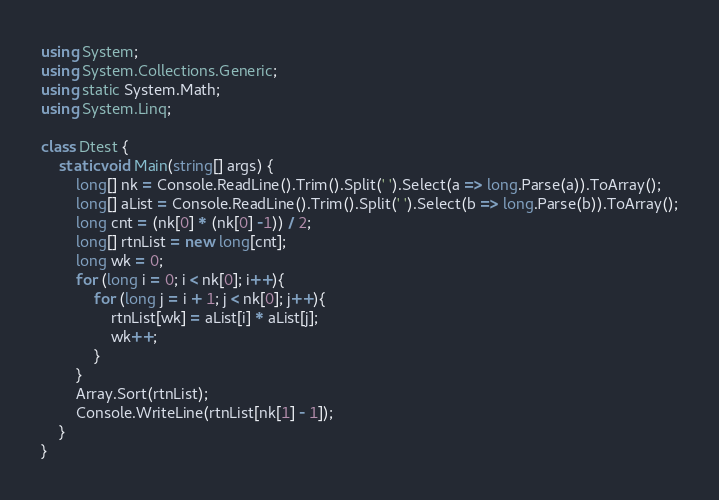Convert code to text. <code><loc_0><loc_0><loc_500><loc_500><_C#_>using System;
using System.Collections.Generic;
using static System.Math;
using System.Linq;

class Dtest {
    static void Main(string[] args) {
        long[] nk = Console.ReadLine().Trim().Split(' ').Select(a => long.Parse(a)).ToArray();
        long[] aList = Console.ReadLine().Trim().Split(' ').Select(b => long.Parse(b)).ToArray();
        long cnt = (nk[0] * (nk[0] -1)) / 2;
        long[] rtnList = new long[cnt];
        long wk = 0;
        for (long i = 0; i < nk[0]; i++){
            for (long j = i + 1; j < nk[0]; j++){
                rtnList[wk] = aList[i] * aList[j];
                wk++;
            }
        }
        Array.Sort(rtnList);
        Console.WriteLine(rtnList[nk[1] - 1]);
    }
}</code> 